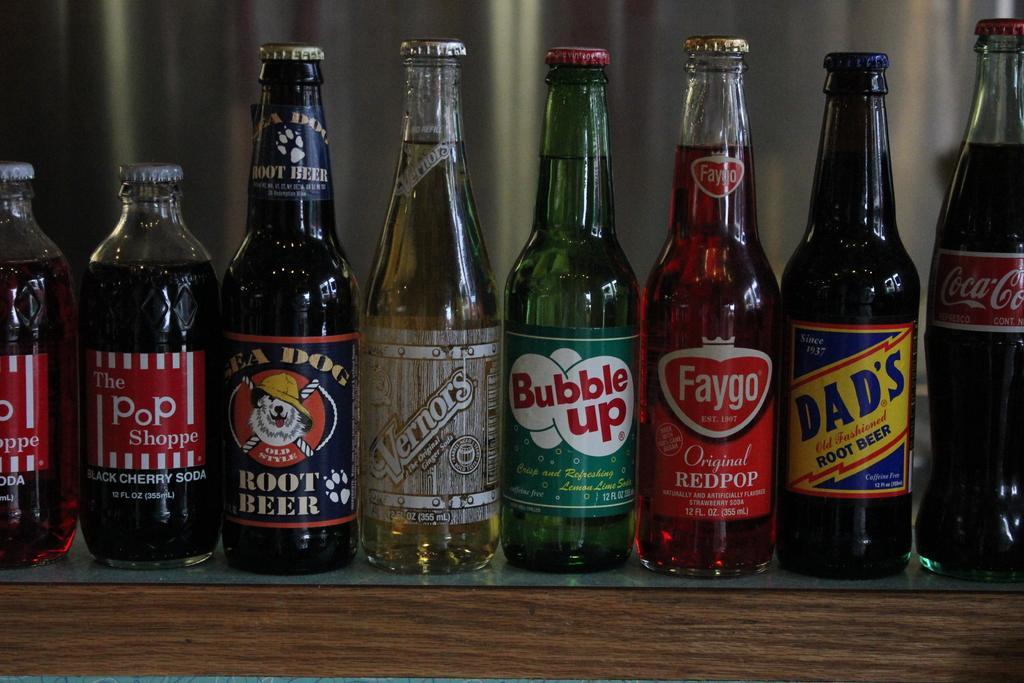Please provide a concise description of this image. In the image there are few bottles on the table. 